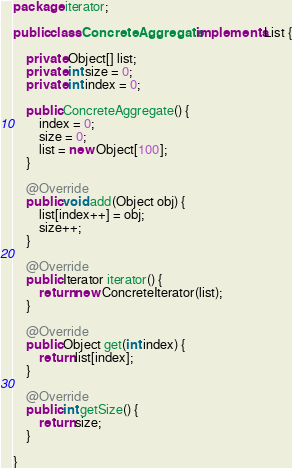Convert code to text. <code><loc_0><loc_0><loc_500><loc_500><_Java_>package iterator;

public class ConcreteAggregate implements List {

    private Object[] list;
    private int size = 0;
    private int index = 0;

    public ConcreteAggregate() {
        index = 0;
        size = 0;
        list = new Object[100];
    }

    @Override
    public void add(Object obj) {
        list[index++] = obj;
        size++;
    }

    @Override
    public Iterator iterator() {
        return new ConcreteIterator(list);
    }

    @Override
    public Object get(int index) {
        return list[index];
    }

    @Override
    public int getSize() {
        return size;
    }

}</code> 